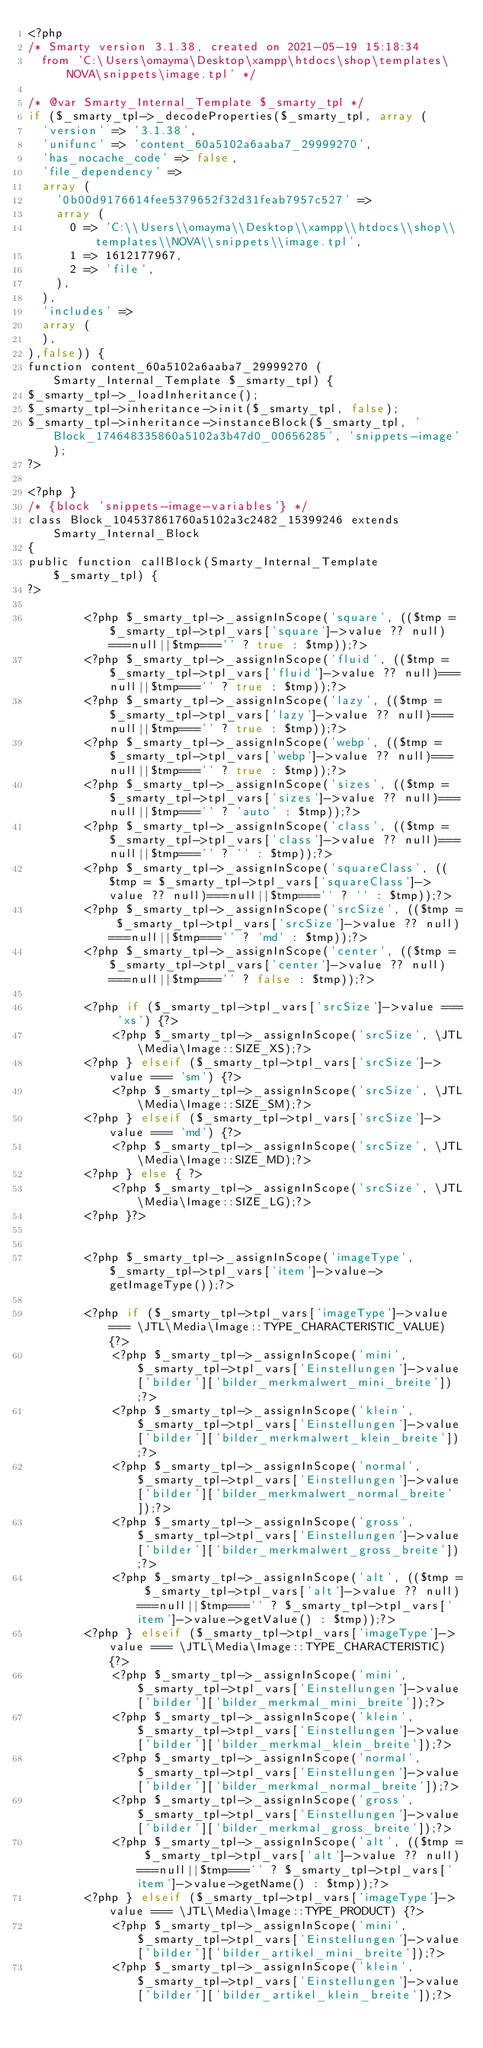<code> <loc_0><loc_0><loc_500><loc_500><_PHP_><?php
/* Smarty version 3.1.38, created on 2021-05-19 15:18:34
  from 'C:\Users\omayma\Desktop\xampp\htdocs\shop\templates\NOVA\snippets\image.tpl' */

/* @var Smarty_Internal_Template $_smarty_tpl */
if ($_smarty_tpl->_decodeProperties($_smarty_tpl, array (
  'version' => '3.1.38',
  'unifunc' => 'content_60a5102a6aaba7_29999270',
  'has_nocache_code' => false,
  'file_dependency' => 
  array (
    '0b00d9176614fee5379652f32d31feab7957c527' => 
    array (
      0 => 'C:\\Users\\omayma\\Desktop\\xampp\\htdocs\\shop\\templates\\NOVA\\snippets\\image.tpl',
      1 => 1612177967,
      2 => 'file',
    ),
  ),
  'includes' => 
  array (
  ),
),false)) {
function content_60a5102a6aaba7_29999270 (Smarty_Internal_Template $_smarty_tpl) {
$_smarty_tpl->_loadInheritance();
$_smarty_tpl->inheritance->init($_smarty_tpl, false);
$_smarty_tpl->inheritance->instanceBlock($_smarty_tpl, 'Block_174648335860a5102a3b47d0_00656285', 'snippets-image');
?>

<?php }
/* {block 'snippets-image-variables'} */
class Block_104537861760a5102a3c2482_15399246 extends Smarty_Internal_Block
{
public function callBlock(Smarty_Internal_Template $_smarty_tpl) {
?>

        <?php $_smarty_tpl->_assignInScope('square', (($tmp = $_smarty_tpl->tpl_vars['square']->value ?? null)===null||$tmp==='' ? true : $tmp));?>
        <?php $_smarty_tpl->_assignInScope('fluid', (($tmp = $_smarty_tpl->tpl_vars['fluid']->value ?? null)===null||$tmp==='' ? true : $tmp));?>
        <?php $_smarty_tpl->_assignInScope('lazy', (($tmp = $_smarty_tpl->tpl_vars['lazy']->value ?? null)===null||$tmp==='' ? true : $tmp));?>
        <?php $_smarty_tpl->_assignInScope('webp', (($tmp = $_smarty_tpl->tpl_vars['webp']->value ?? null)===null||$tmp==='' ? true : $tmp));?>
        <?php $_smarty_tpl->_assignInScope('sizes', (($tmp = $_smarty_tpl->tpl_vars['sizes']->value ?? null)===null||$tmp==='' ? 'auto' : $tmp));?>
        <?php $_smarty_tpl->_assignInScope('class', (($tmp = $_smarty_tpl->tpl_vars['class']->value ?? null)===null||$tmp==='' ? '' : $tmp));?>
        <?php $_smarty_tpl->_assignInScope('squareClass', (($tmp = $_smarty_tpl->tpl_vars['squareClass']->value ?? null)===null||$tmp==='' ? '' : $tmp));?>
        <?php $_smarty_tpl->_assignInScope('srcSize', (($tmp = $_smarty_tpl->tpl_vars['srcSize']->value ?? null)===null||$tmp==='' ? 'md' : $tmp));?>
        <?php $_smarty_tpl->_assignInScope('center', (($tmp = $_smarty_tpl->tpl_vars['center']->value ?? null)===null||$tmp==='' ? false : $tmp));?>

        <?php if ($_smarty_tpl->tpl_vars['srcSize']->value === 'xs') {?>
            <?php $_smarty_tpl->_assignInScope('srcSize', \JTL\Media\Image::SIZE_XS);?>
        <?php } elseif ($_smarty_tpl->tpl_vars['srcSize']->value === 'sm') {?>
            <?php $_smarty_tpl->_assignInScope('srcSize', \JTL\Media\Image::SIZE_SM);?>
        <?php } elseif ($_smarty_tpl->tpl_vars['srcSize']->value === 'md') {?>
            <?php $_smarty_tpl->_assignInScope('srcSize', \JTL\Media\Image::SIZE_MD);?>
        <?php } else { ?>
            <?php $_smarty_tpl->_assignInScope('srcSize', \JTL\Media\Image::SIZE_LG);?>
        <?php }?>


        <?php $_smarty_tpl->_assignInScope('imageType', $_smarty_tpl->tpl_vars['item']->value->getImageType());?>

        <?php if ($_smarty_tpl->tpl_vars['imageType']->value === \JTL\Media\Image::TYPE_CHARACTERISTIC_VALUE) {?>
            <?php $_smarty_tpl->_assignInScope('mini', $_smarty_tpl->tpl_vars['Einstellungen']->value['bilder']['bilder_merkmalwert_mini_breite']);?>
            <?php $_smarty_tpl->_assignInScope('klein', $_smarty_tpl->tpl_vars['Einstellungen']->value['bilder']['bilder_merkmalwert_klein_breite']);?>
            <?php $_smarty_tpl->_assignInScope('normal', $_smarty_tpl->tpl_vars['Einstellungen']->value['bilder']['bilder_merkmalwert_normal_breite']);?>
            <?php $_smarty_tpl->_assignInScope('gross', $_smarty_tpl->tpl_vars['Einstellungen']->value['bilder']['bilder_merkmalwert_gross_breite']);?>
            <?php $_smarty_tpl->_assignInScope('alt', (($tmp = $_smarty_tpl->tpl_vars['alt']->value ?? null)===null||$tmp==='' ? $_smarty_tpl->tpl_vars['item']->value->getValue() : $tmp));?>
        <?php } elseif ($_smarty_tpl->tpl_vars['imageType']->value === \JTL\Media\Image::TYPE_CHARACTERISTIC) {?>
            <?php $_smarty_tpl->_assignInScope('mini', $_smarty_tpl->tpl_vars['Einstellungen']->value['bilder']['bilder_merkmal_mini_breite']);?>
            <?php $_smarty_tpl->_assignInScope('klein', $_smarty_tpl->tpl_vars['Einstellungen']->value['bilder']['bilder_merkmal_klein_breite']);?>
            <?php $_smarty_tpl->_assignInScope('normal', $_smarty_tpl->tpl_vars['Einstellungen']->value['bilder']['bilder_merkmal_normal_breite']);?>
            <?php $_smarty_tpl->_assignInScope('gross', $_smarty_tpl->tpl_vars['Einstellungen']->value['bilder']['bilder_merkmal_gross_breite']);?>
            <?php $_smarty_tpl->_assignInScope('alt', (($tmp = $_smarty_tpl->tpl_vars['alt']->value ?? null)===null||$tmp==='' ? $_smarty_tpl->tpl_vars['item']->value->getName() : $tmp));?>
        <?php } elseif ($_smarty_tpl->tpl_vars['imageType']->value === \JTL\Media\Image::TYPE_PRODUCT) {?>
            <?php $_smarty_tpl->_assignInScope('mini', $_smarty_tpl->tpl_vars['Einstellungen']->value['bilder']['bilder_artikel_mini_breite']);?>
            <?php $_smarty_tpl->_assignInScope('klein', $_smarty_tpl->tpl_vars['Einstellungen']->value['bilder']['bilder_artikel_klein_breite']);?></code> 